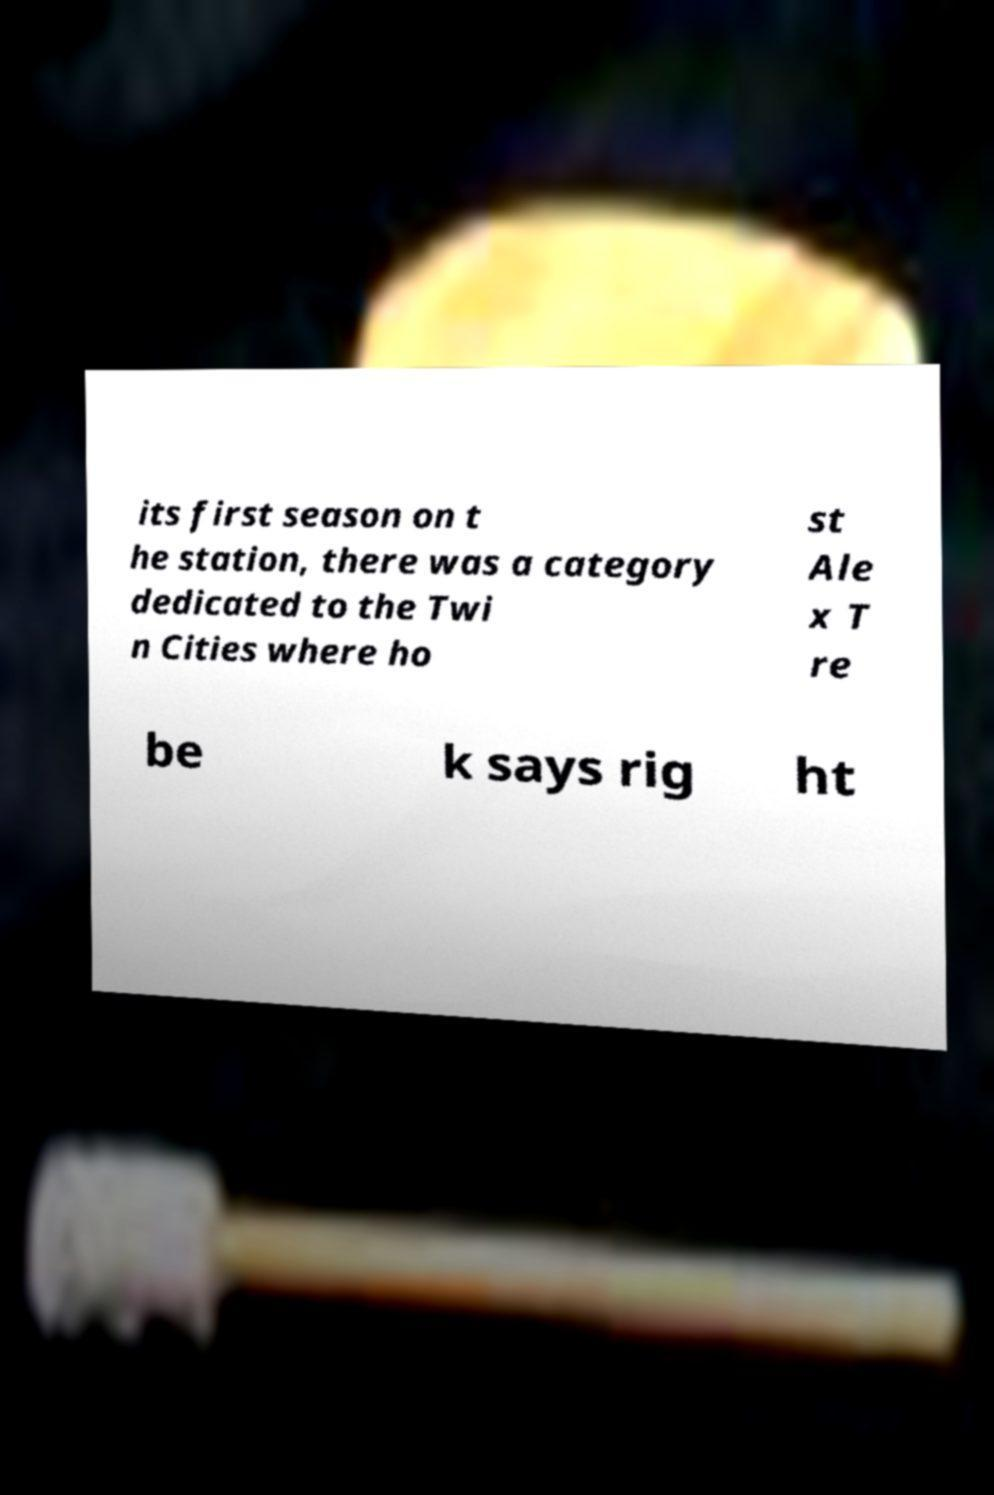Can you accurately transcribe the text from the provided image for me? its first season on t he station, there was a category dedicated to the Twi n Cities where ho st Ale x T re be k says rig ht 